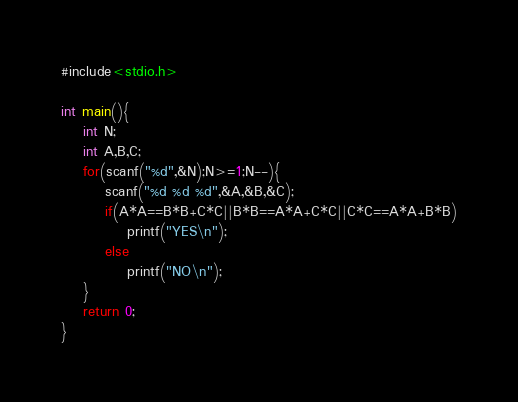<code> <loc_0><loc_0><loc_500><loc_500><_C_>#include<stdio.h>

int main(){
	int N;
	int A,B,C;
	for(scanf("%d",&N);N>=1;N--){
		scanf("%d %d %d",&A,&B,&C);
		if(A*A==B*B+C*C||B*B==A*A+C*C||C*C==A*A+B*B)
			printf("YES\n");
		else	
			printf("NO\n");
	}
	return 0;
}</code> 